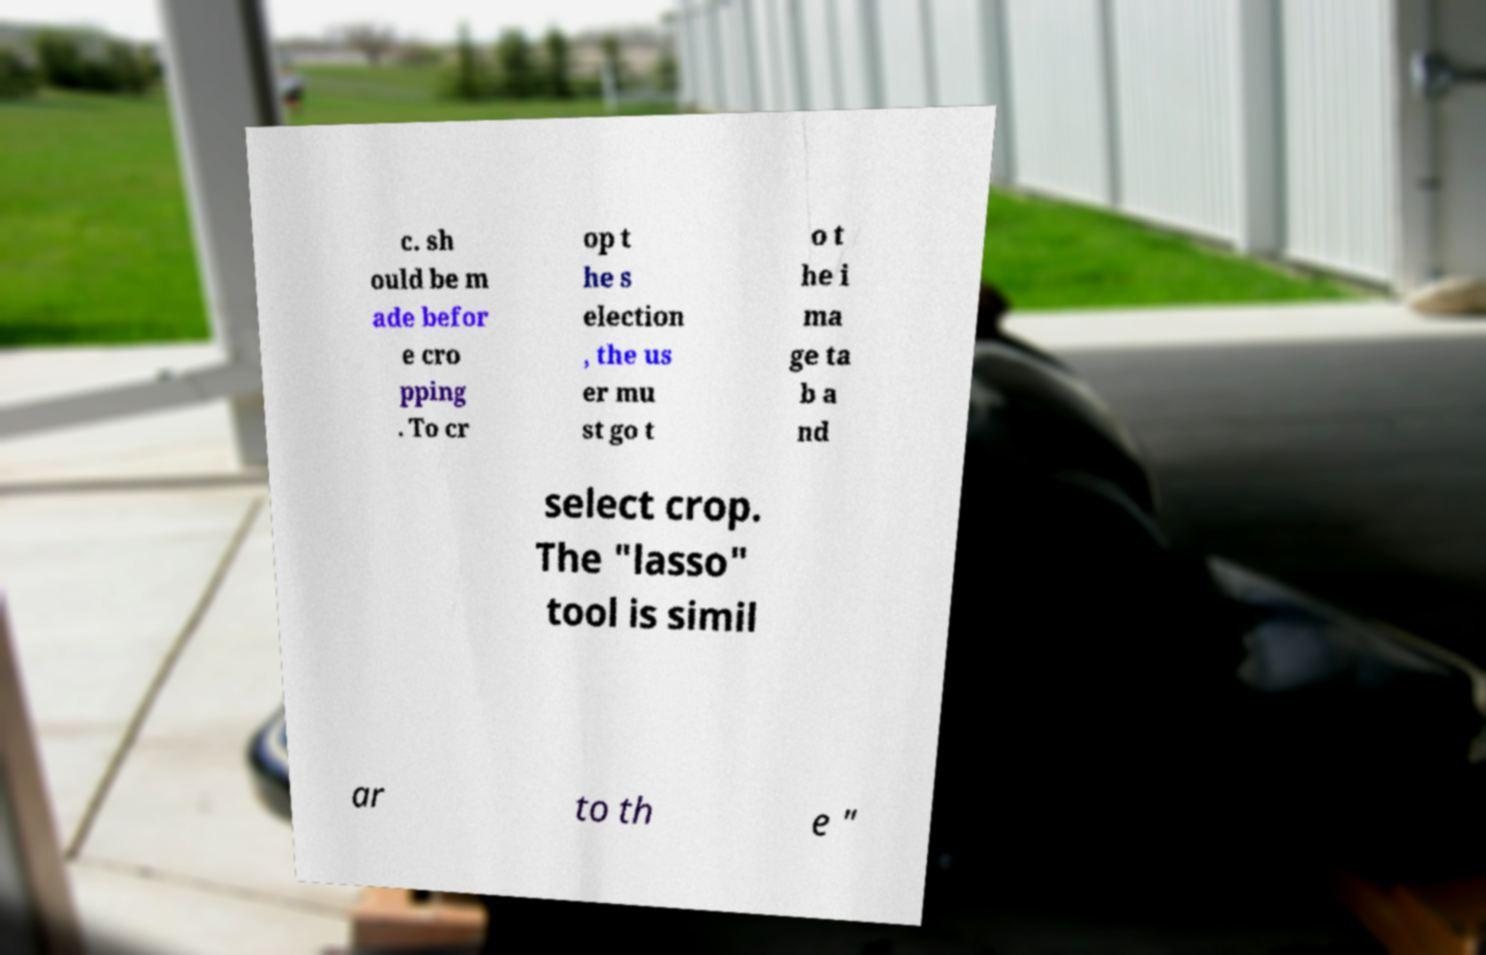Please identify and transcribe the text found in this image. c. sh ould be m ade befor e cro pping . To cr op t he s election , the us er mu st go t o t he i ma ge ta b a nd select crop. The "lasso" tool is simil ar to th e " 